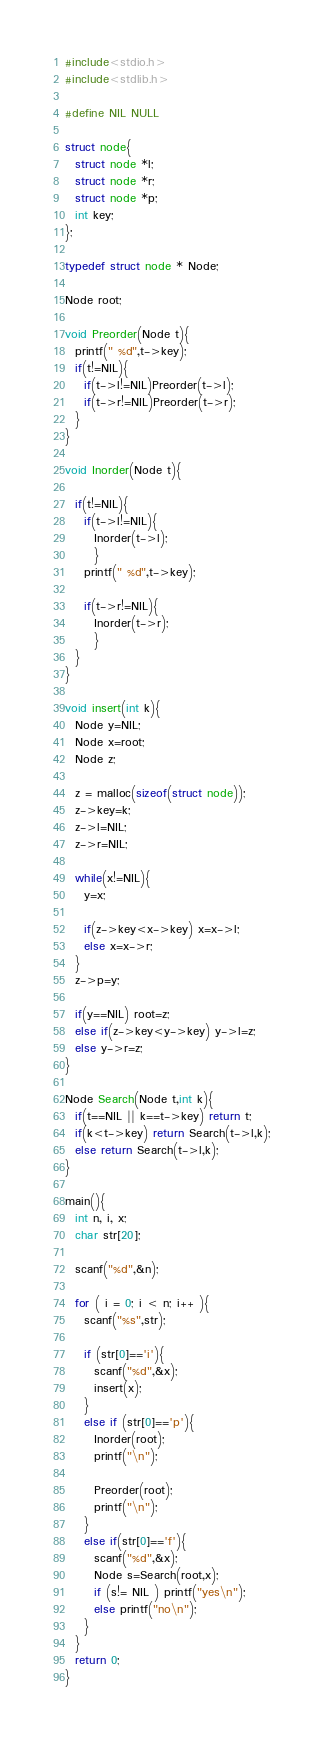Convert code to text. <code><loc_0><loc_0><loc_500><loc_500><_C_>#include<stdio.h>
#include<stdlib.h>

#define NIL NULL

struct node{
  struct node *l;
  struct node *r;
  struct node *p;
  int key;
};

typedef struct node * Node;

Node root;

void Preorder(Node t){
  printf(" %d",t->key);
  if(t!=NIL){
    if(t->l!=NIL)Preorder(t->l);
    if(t->r!=NIL)Preorder(t->r);
  }
}

void Inorder(Node t){
  
  if(t!=NIL){
    if(t->l!=NIL){
      Inorder(t->l);
      }
    printf(" %d",t->key);
    
    if(t->r!=NIL){
      Inorder(t->r);
      }
  }
}

void insert(int k){
  Node y=NIL;
  Node x=root;
  Node z;

  z = malloc(sizeof(struct node));
  z->key=k;
  z->l=NIL;
  z->r=NIL;
  
  while(x!=NIL){
    y=x;

    if(z->key<x->key) x=x->l;
    else x=x->r;
  }
  z->p=y;
  
  if(y==NIL) root=z;
  else if(z->key<y->key) y->l=z;
  else y->r=z;
}

Node Search(Node t,int k){
  if(t==NIL || k==t->key) return t;
  if(k<t->key) return Search(t->l,k);
  else return Search(t->l,k);
}

main(){
  int n, i, x;
  char str[20];
  
  scanf("%d",&n);

  for ( i = 0; i < n; i++ ){
    scanf("%s",str);

    if (str[0]=='i'){
      scanf("%d",&x);
      insert(x);
    } 
    else if (str[0]=='p'){
      Inorder(root);
      printf("\n");
      
      Preorder(root);
      printf("\n");
    }
    else if(str[0]=='f'){
      scanf("%d",&x);
      Node s=Search(root,x);
      if (s!= NIL ) printf("yes\n");
      else printf("no\n");
    }
  }
  return 0;
}</code> 